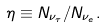Convert formula to latex. <formula><loc_0><loc_0><loc_500><loc_500>\eta \equiv N _ { \nu _ { \tau } } / N _ { \nu _ { e } } .</formula> 